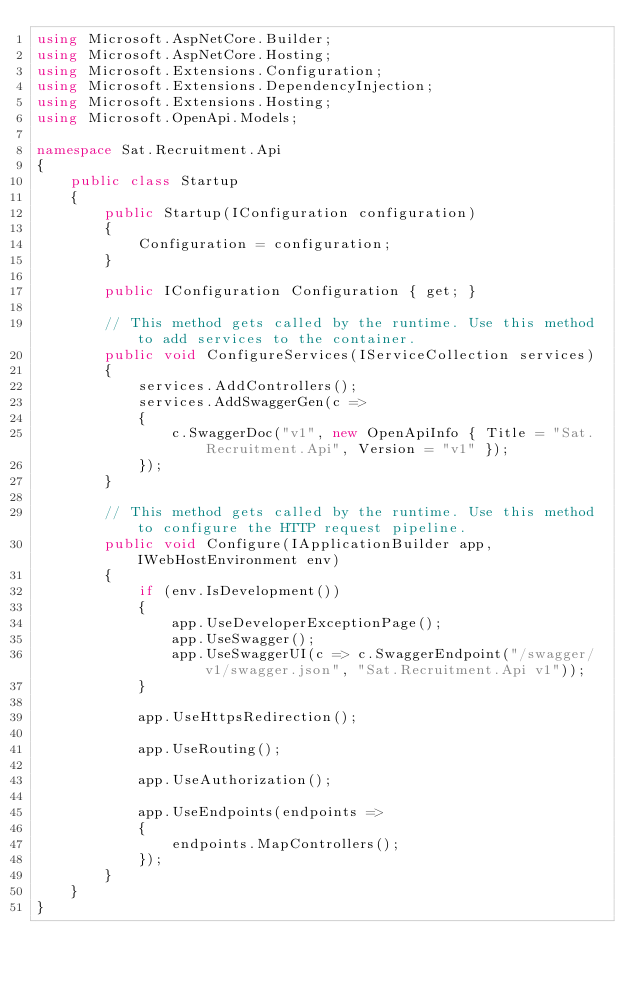Convert code to text. <code><loc_0><loc_0><loc_500><loc_500><_C#_>using Microsoft.AspNetCore.Builder;
using Microsoft.AspNetCore.Hosting;
using Microsoft.Extensions.Configuration;
using Microsoft.Extensions.DependencyInjection;
using Microsoft.Extensions.Hosting;
using Microsoft.OpenApi.Models;

namespace Sat.Recruitment.Api
{
    public class Startup
    {
        public Startup(IConfiguration configuration)
        {
            Configuration = configuration;
        }

        public IConfiguration Configuration { get; }

        // This method gets called by the runtime. Use this method to add services to the container.
        public void ConfigureServices(IServiceCollection services)
        {
            services.AddControllers();
            services.AddSwaggerGen(c =>
            {
                c.SwaggerDoc("v1", new OpenApiInfo { Title = "Sat.Recruitment.Api", Version = "v1" });
            });
        }

        // This method gets called by the runtime. Use this method to configure the HTTP request pipeline.
        public void Configure(IApplicationBuilder app, IWebHostEnvironment env)
        {
            if (env.IsDevelopment())
            {
                app.UseDeveloperExceptionPage();
                app.UseSwagger();
                app.UseSwaggerUI(c => c.SwaggerEndpoint("/swagger/v1/swagger.json", "Sat.Recruitment.Api v1"));
            }

            app.UseHttpsRedirection();

            app.UseRouting();

            app.UseAuthorization();

            app.UseEndpoints(endpoints =>
            {
                endpoints.MapControllers();
            });
        }
    }
}</code> 